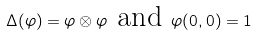Convert formula to latex. <formula><loc_0><loc_0><loc_500><loc_500>\Delta ( \varphi ) = \varphi \otimes \varphi \text { and } \varphi ( 0 , 0 ) = 1</formula> 